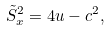Convert formula to latex. <formula><loc_0><loc_0><loc_500><loc_500>\tilde { S } _ { x } ^ { 2 } = 4 u - c ^ { 2 } ,</formula> 